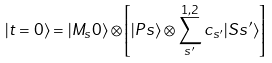Convert formula to latex. <formula><loc_0><loc_0><loc_500><loc_500>| t = 0 \rangle = | M _ { s } 0 \rangle \otimes \left [ | P s \rangle \otimes \sum _ { s ^ { \prime } } ^ { 1 , 2 } c _ { s ^ { \prime } } | S s ^ { \prime } \rangle \right ]</formula> 